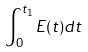Convert formula to latex. <formula><loc_0><loc_0><loc_500><loc_500>\int _ { 0 } ^ { t _ { 1 } } E ( t ) d t</formula> 